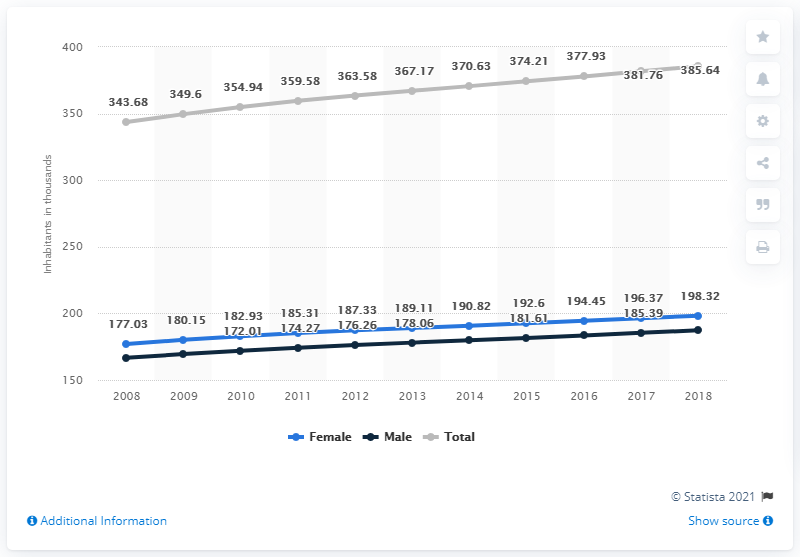Can you explain the trend in female population growth from 2010 to 2018? The female population has shown a steady increase from 2010 to 2018. Starting at approximately 176.26 million in 2010, it grew to about 198.32 million by 2018. This steady rise indicates consistent growth, likely due to factors such as improved healthcare and societal shifts promoting gender equality. 